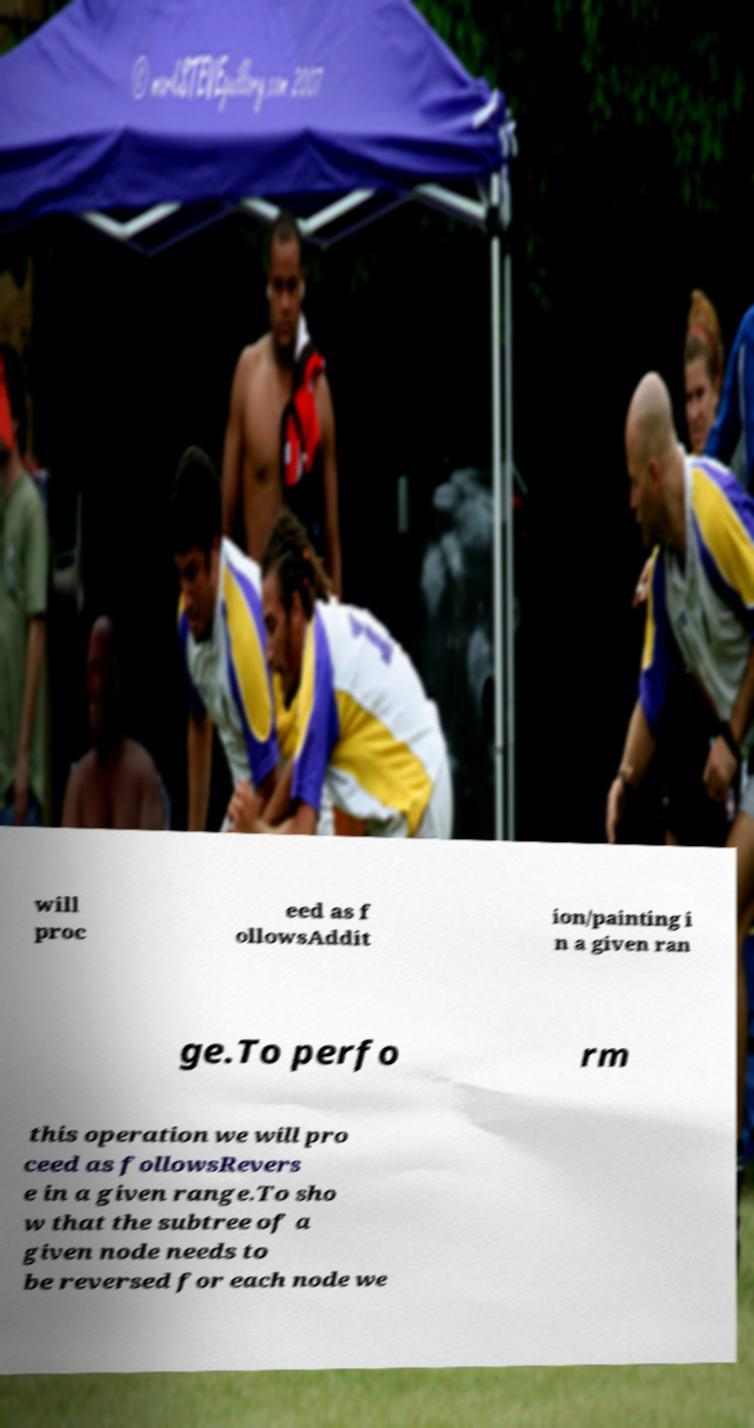Please read and relay the text visible in this image. What does it say? will proc eed as f ollowsAddit ion/painting i n a given ran ge.To perfo rm this operation we will pro ceed as followsRevers e in a given range.To sho w that the subtree of a given node needs to be reversed for each node we 